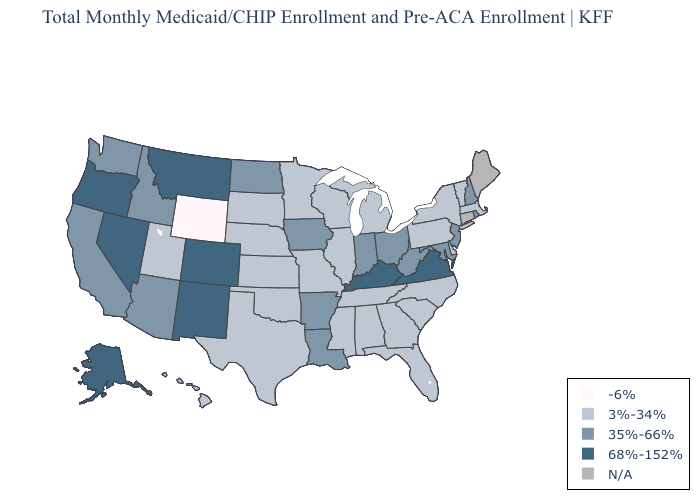Name the states that have a value in the range 68%-152%?
Answer briefly. Alaska, Colorado, Kentucky, Montana, Nevada, New Mexico, Oregon, Virginia. Name the states that have a value in the range 68%-152%?
Answer briefly. Alaska, Colorado, Kentucky, Montana, Nevada, New Mexico, Oregon, Virginia. What is the lowest value in the USA?
Give a very brief answer. -6%. What is the lowest value in the USA?
Write a very short answer. -6%. Does Maryland have the lowest value in the USA?
Give a very brief answer. No. Which states hav the highest value in the West?
Short answer required. Alaska, Colorado, Montana, Nevada, New Mexico, Oregon. What is the value of Mississippi?
Keep it brief. 3%-34%. What is the value of Alaska?
Keep it brief. 68%-152%. Does the first symbol in the legend represent the smallest category?
Be succinct. Yes. Name the states that have a value in the range 3%-34%?
Quick response, please. Alabama, Delaware, Florida, Georgia, Hawaii, Illinois, Kansas, Massachusetts, Michigan, Minnesota, Mississippi, Missouri, Nebraska, New York, North Carolina, Oklahoma, Pennsylvania, South Carolina, South Dakota, Tennessee, Texas, Utah, Vermont, Wisconsin. Does Wyoming have the lowest value in the USA?
Write a very short answer. Yes. Name the states that have a value in the range N/A?
Give a very brief answer. Connecticut, Maine. Which states hav the highest value in the MidWest?
Quick response, please. Indiana, Iowa, North Dakota, Ohio. 